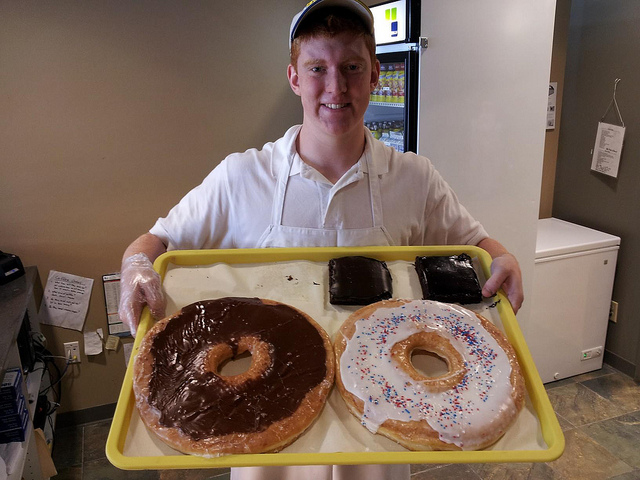Are these baked goods likely to be as tasty as their regular-sized counterparts? While the novelty size is visually impressive, there may be some differences in texture or baking quality due to the scale, but generally, they are made with the same ingredients and aim to preserve the taste of their regular-sized counterparts. 